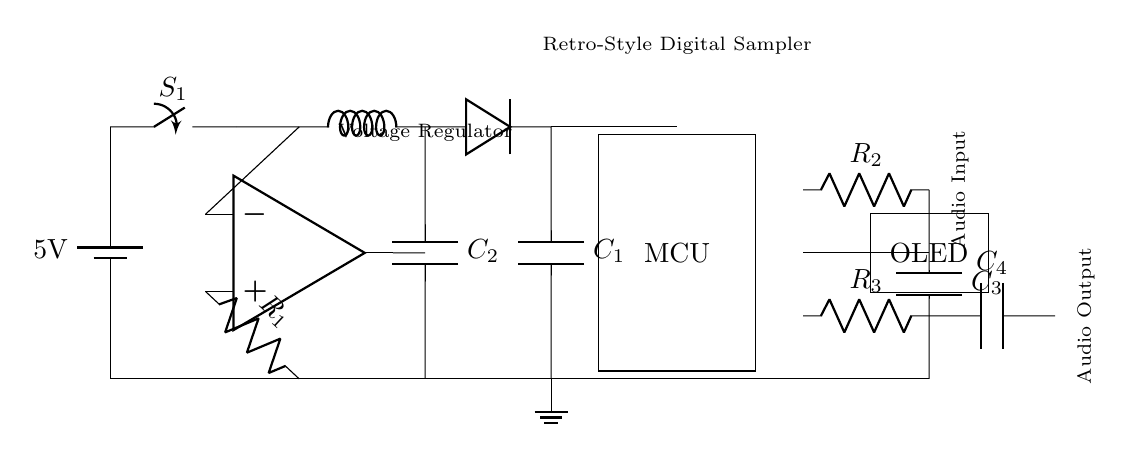What is the main power source voltage? The circuit uses a battery as the main power source, and the voltage of the battery is labeled as 5 volts.
Answer: 5 volts What component regulates voltage in this circuit? The voltage regulator is identified by the label in the circuit, which is positioned after the main power switch.
Answer: Voltage regulator Which component connects to the audio input? The resistor labeled as R2 is in series with the capacitor C3, forming the connection to the audio input.
Answer: Resistor R2 What type of display is used in this circuit? The circuit diagram shows an OLED display, which is labeled as a rectangle near the DAC output.
Answer: OLED display How many capacitors are there in this circuit? The circuit features four capacitors: C1, C2, C3, and C4, each located at different points in the circuit.
Answer: Four capacitors Explain the connection between the voltage regulator and the microcontroller. The output of the voltage regulator leads to the microcontroller (MCU) through a direct connection, providing power to it. This connection is essential for powering the MCU with regulated voltage.
Answer: Direct connection What is the purpose of the diode in this circuit? The diode is placed after the inductor and before the capacitor C1, typically used for rectification and to prevent reverse current flow, ensuring the proper direction of current to the load.
Answer: Prevents reverse current 